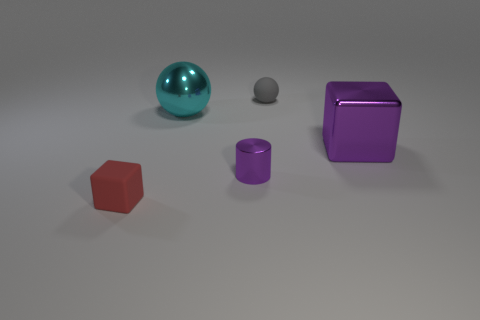How might you imagine these objects being used in a real-world setting? In a real-world setting, the objects could resemble children's toys, designed for both educational and entertainment purposes, helping kids learn about shapes and colors. 